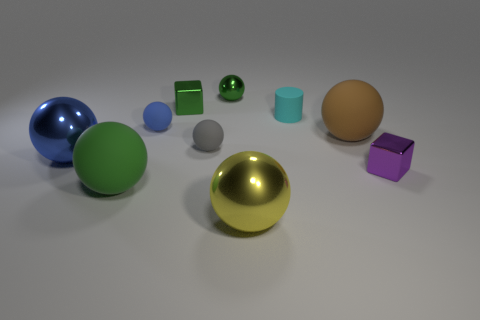The matte object that is the same color as the small metallic sphere is what size?
Your answer should be very brief. Large. There is a green thing that is in front of the purple block; what shape is it?
Give a very brief answer. Sphere. What color is the matte sphere that is right of the large yellow sphere that is in front of the big thing right of the large yellow sphere?
Make the answer very short. Brown. Does the small green ball have the same material as the cyan thing?
Your answer should be very brief. No. What number of green objects are either small metal cylinders or cubes?
Offer a terse response. 1. There is a yellow shiny thing; what number of green cubes are in front of it?
Your response must be concise. 0. Are there more large blue objects than small green metallic things?
Offer a very short reply. No. What is the shape of the shiny object to the left of the large rubber ball that is to the left of the tiny blue ball?
Provide a short and direct response. Sphere. Do the rubber cylinder and the tiny metal sphere have the same color?
Ensure brevity in your answer.  No. Are there more tiny matte things that are left of the blue rubber sphere than purple things?
Ensure brevity in your answer.  No. 